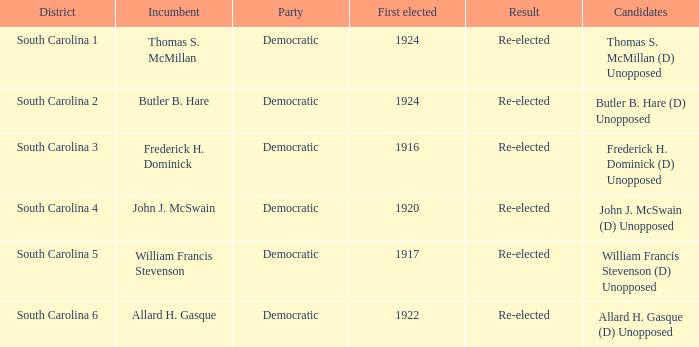Who is the candidate in district south carolina 2? Butler B. Hare (D) Unopposed. 